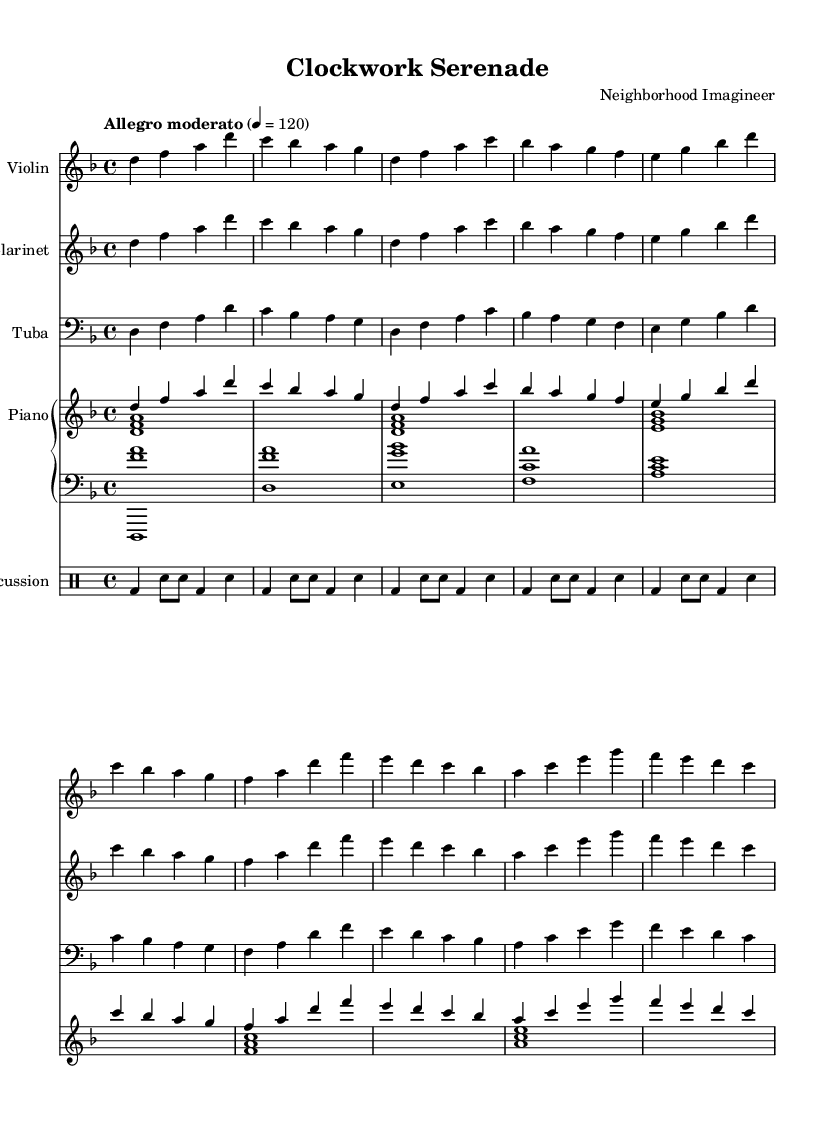What is the key signature of this music? The key signature shows two flats, indicating the music is in D minor.
Answer: D minor What is the time signature of the score? The time signature is notated as four beats per measure, which is indicated by the 4/4 marking.
Answer: 4/4 What tempo marking is indicated? The score indicates "Allegro moderato" with a metronome marking of 120 beats per minute.
Answer: Allegro moderato How many measures are there in each instrument's part? Each instrument's part consists of five measures, as can be visually counted in the respective staves.
Answer: Five Which instruments are present in this piece? The piece features a violin, clarinet, tuba, piano, and percussion as indicated by the labeled staves.
Answer: Violin, clarinet, tuba, piano, percussion What kind of fusion is this music representing? The music combines elements of jazz and classical styles, specifically influenced by steampunk aesthetics fit for Victorian-era adventures.
Answer: Steampunk jazz-classical fusion 